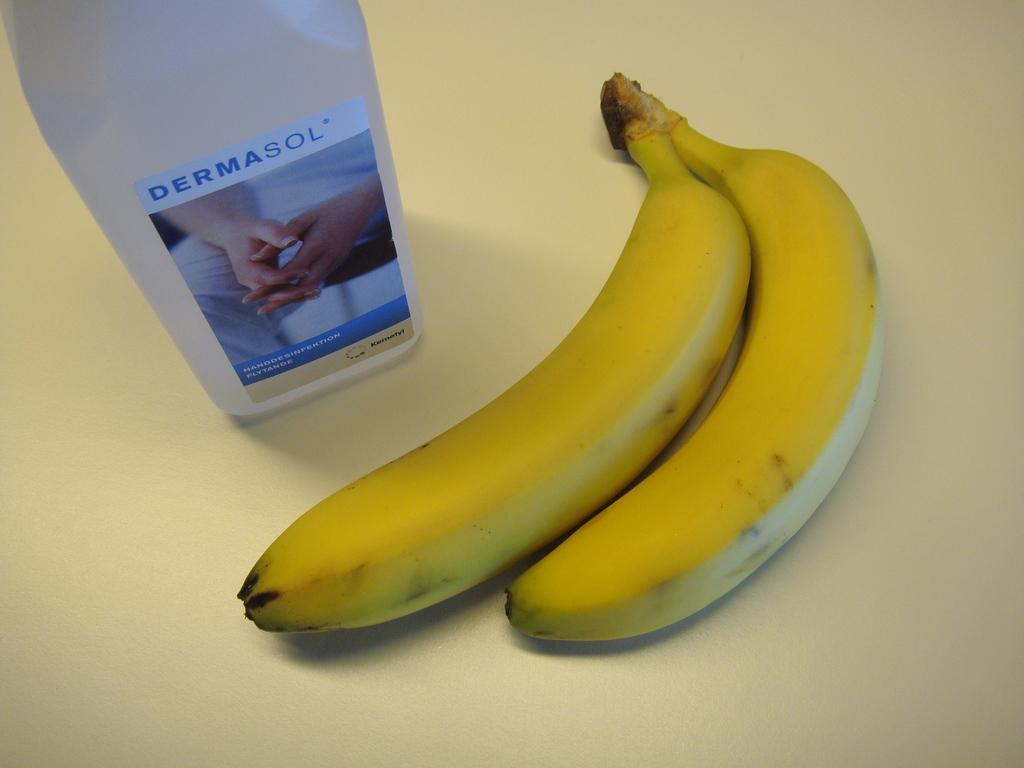In one or two sentences, can you explain what this image depicts? In the center of the image there are bananas. There is a bottle on the table. 